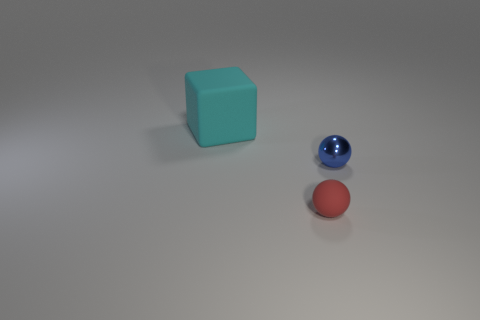Does the small thing that is left of the blue thing have the same color as the thing that is behind the metallic thing?
Offer a very short reply. No. Is there a matte object that has the same color as the block?
Make the answer very short. No. What number of other things are the same shape as the big object?
Keep it short and to the point. 0. What is the shape of the rubber object that is right of the rubber block?
Your response must be concise. Sphere. There is a tiny rubber object; is its shape the same as the thing behind the blue ball?
Keep it short and to the point. No. What size is the object that is both on the left side of the metal ball and to the right of the big cyan rubber object?
Your answer should be very brief. Small. The thing that is in front of the cyan rubber cube and on the left side of the small blue metal thing is what color?
Provide a short and direct response. Red. Is there anything else that is made of the same material as the large object?
Offer a very short reply. Yes. Is the number of small blue shiny spheres that are behind the cyan rubber object less than the number of cyan cubes in front of the blue object?
Make the answer very short. No. Are there any other things of the same color as the tiny shiny ball?
Ensure brevity in your answer.  No. 